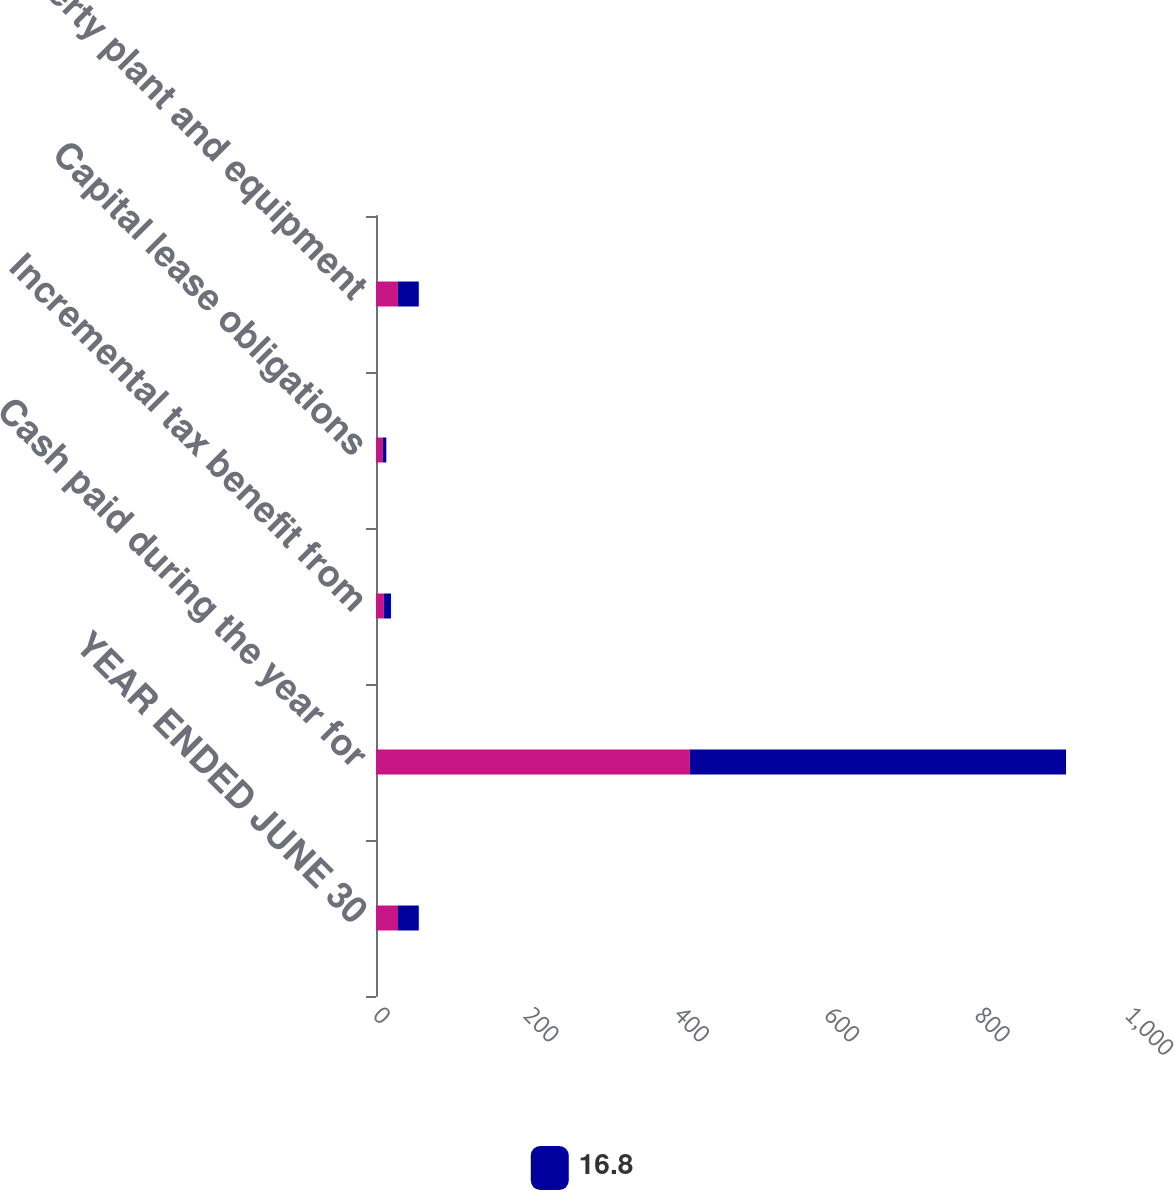Convert chart to OTSL. <chart><loc_0><loc_0><loc_500><loc_500><stacked_bar_chart><ecel><fcel>YEAR ENDED JUNE 30<fcel>Cash paid during the year for<fcel>Incremental tax benefit from<fcel>Capital lease obligations<fcel>Property plant and equipment<nl><fcel>nan<fcel>28.45<fcel>417.4<fcel>10.1<fcel>8.7<fcel>28.6<nl><fcel>16.8<fcel>28.45<fcel>500.2<fcel>9.8<fcel>5<fcel>28.3<nl></chart> 